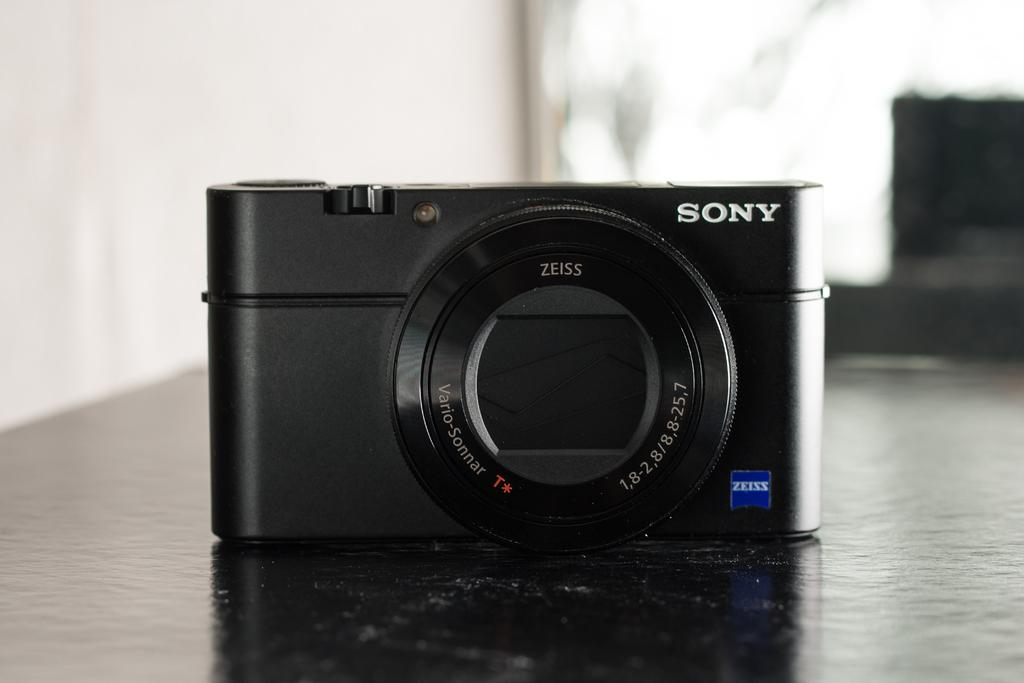<image>
Describe the image concisely. a Sony camera with a Zeiss lens on a table 